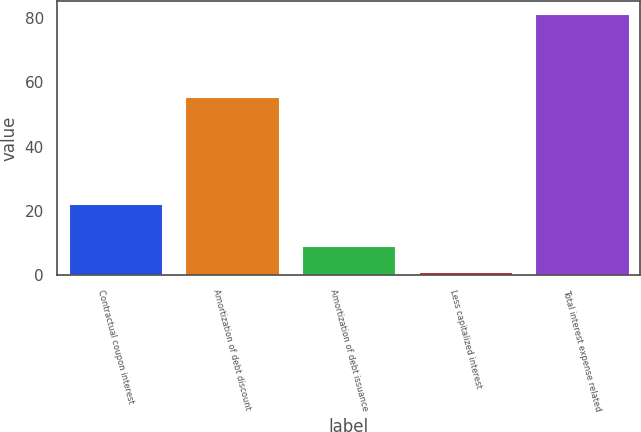<chart> <loc_0><loc_0><loc_500><loc_500><bar_chart><fcel>Contractual coupon interest<fcel>Amortization of debt discount<fcel>Amortization of debt issuance<fcel>Less capitalized interest<fcel>Total interest expense related<nl><fcel>22<fcel>55.5<fcel>9.11<fcel>1.1<fcel>81.2<nl></chart> 